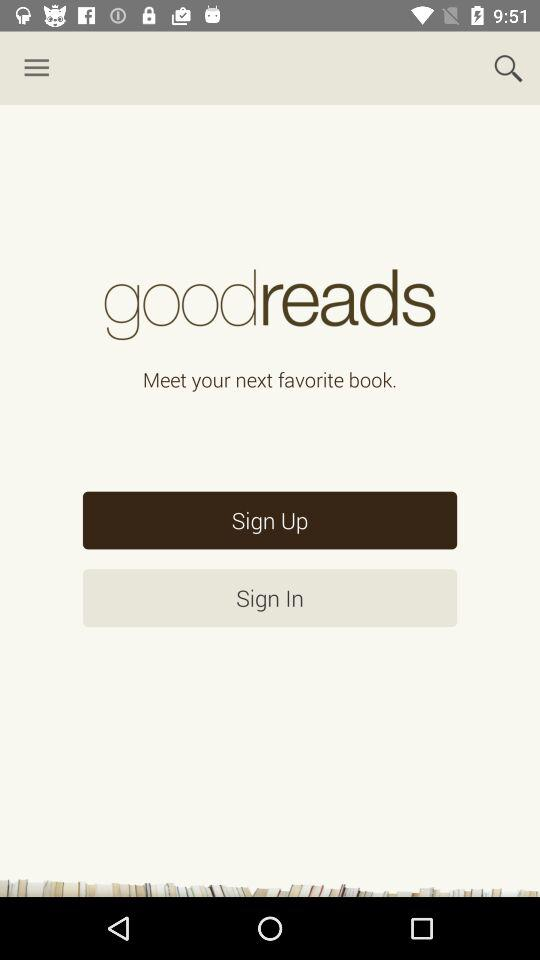What's the selected option for starting the Application?
When the provided information is insufficient, respond with <no answer>. <no answer> 